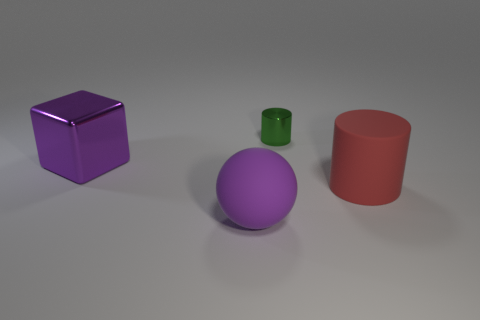Is there anything else that has the same size as the green metallic cylinder?
Ensure brevity in your answer.  No. Is the shape of the small green thing the same as the purple matte thing?
Keep it short and to the point. No. What is the color of the large rubber object that is the same shape as the tiny green thing?
Offer a terse response. Red. What number of big metal cubes are the same color as the big matte sphere?
Keep it short and to the point. 1. How many objects are either large objects to the right of the purple sphere or red rubber objects?
Ensure brevity in your answer.  1. What is the size of the object behind the large purple metal block?
Your answer should be compact. Small. Are there fewer big red rubber cylinders than purple things?
Ensure brevity in your answer.  Yes. Does the thing that is right of the tiny object have the same material as the thing that is in front of the big red matte thing?
Provide a short and direct response. Yes. There is a big purple object that is behind the matte object that is behind the big purple object that is in front of the red cylinder; what shape is it?
Your answer should be compact. Cube. What number of red objects have the same material as the block?
Offer a very short reply. 0. 